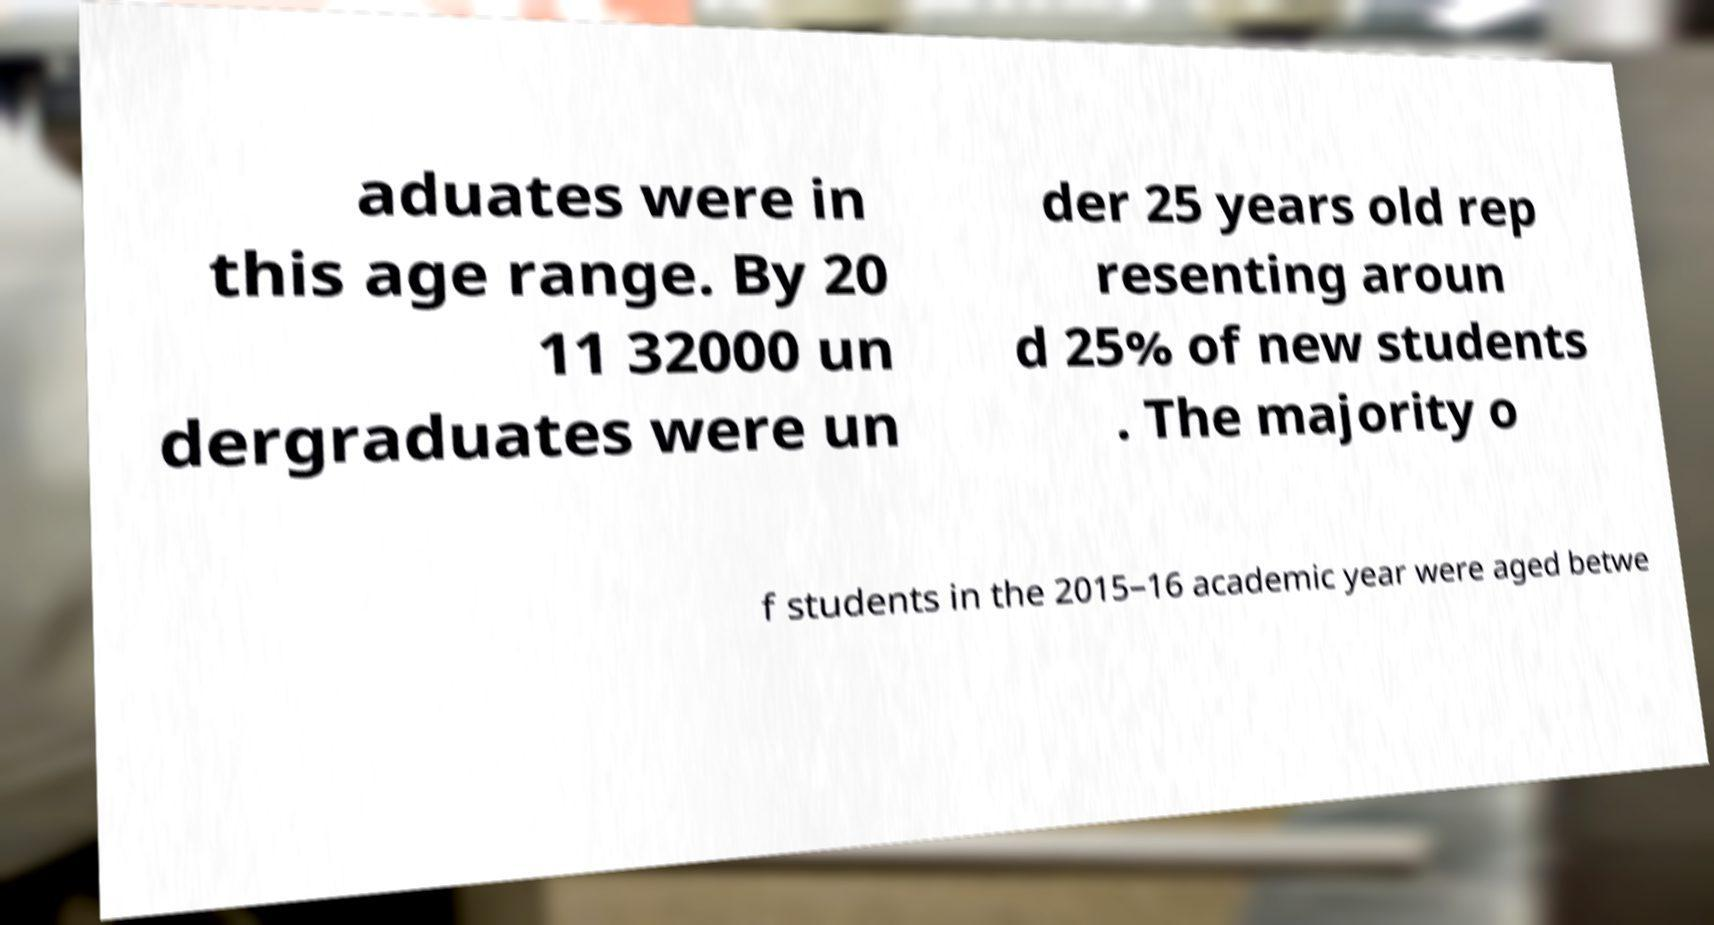For documentation purposes, I need the text within this image transcribed. Could you provide that? aduates were in this age range. By 20 11 32000 un dergraduates were un der 25 years old rep resenting aroun d 25% of new students . The majority o f students in the 2015–16 academic year were aged betwe 